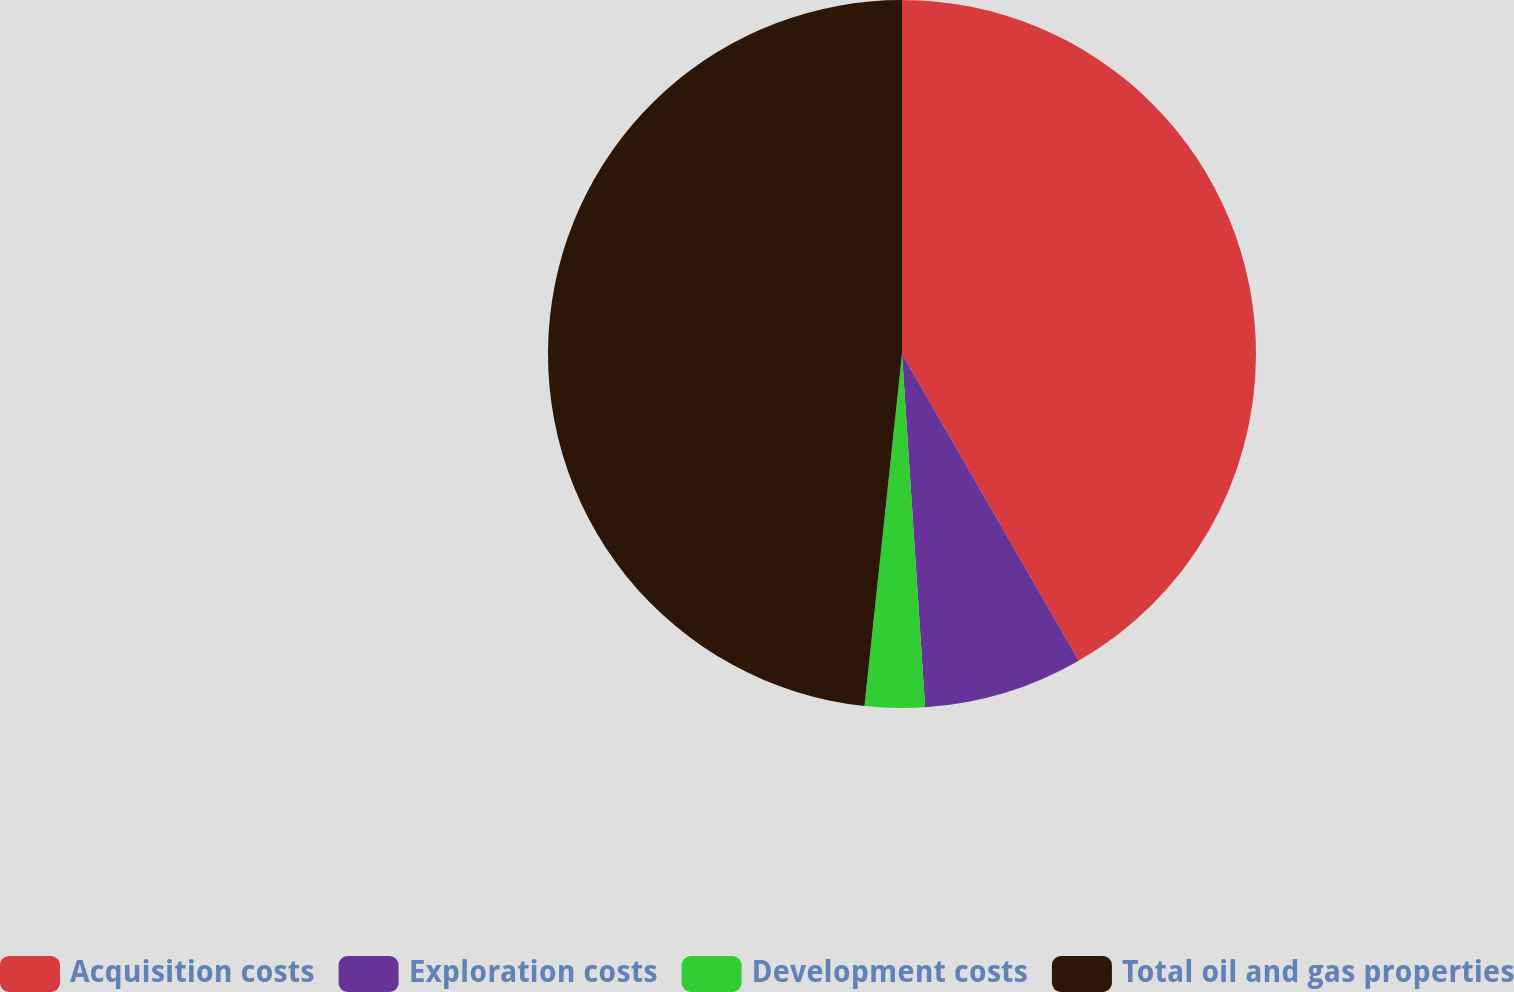Convert chart. <chart><loc_0><loc_0><loc_500><loc_500><pie_chart><fcel>Acquisition costs<fcel>Exploration costs<fcel>Development costs<fcel>Total oil and gas properties<nl><fcel>41.68%<fcel>7.28%<fcel>2.73%<fcel>48.31%<nl></chart> 